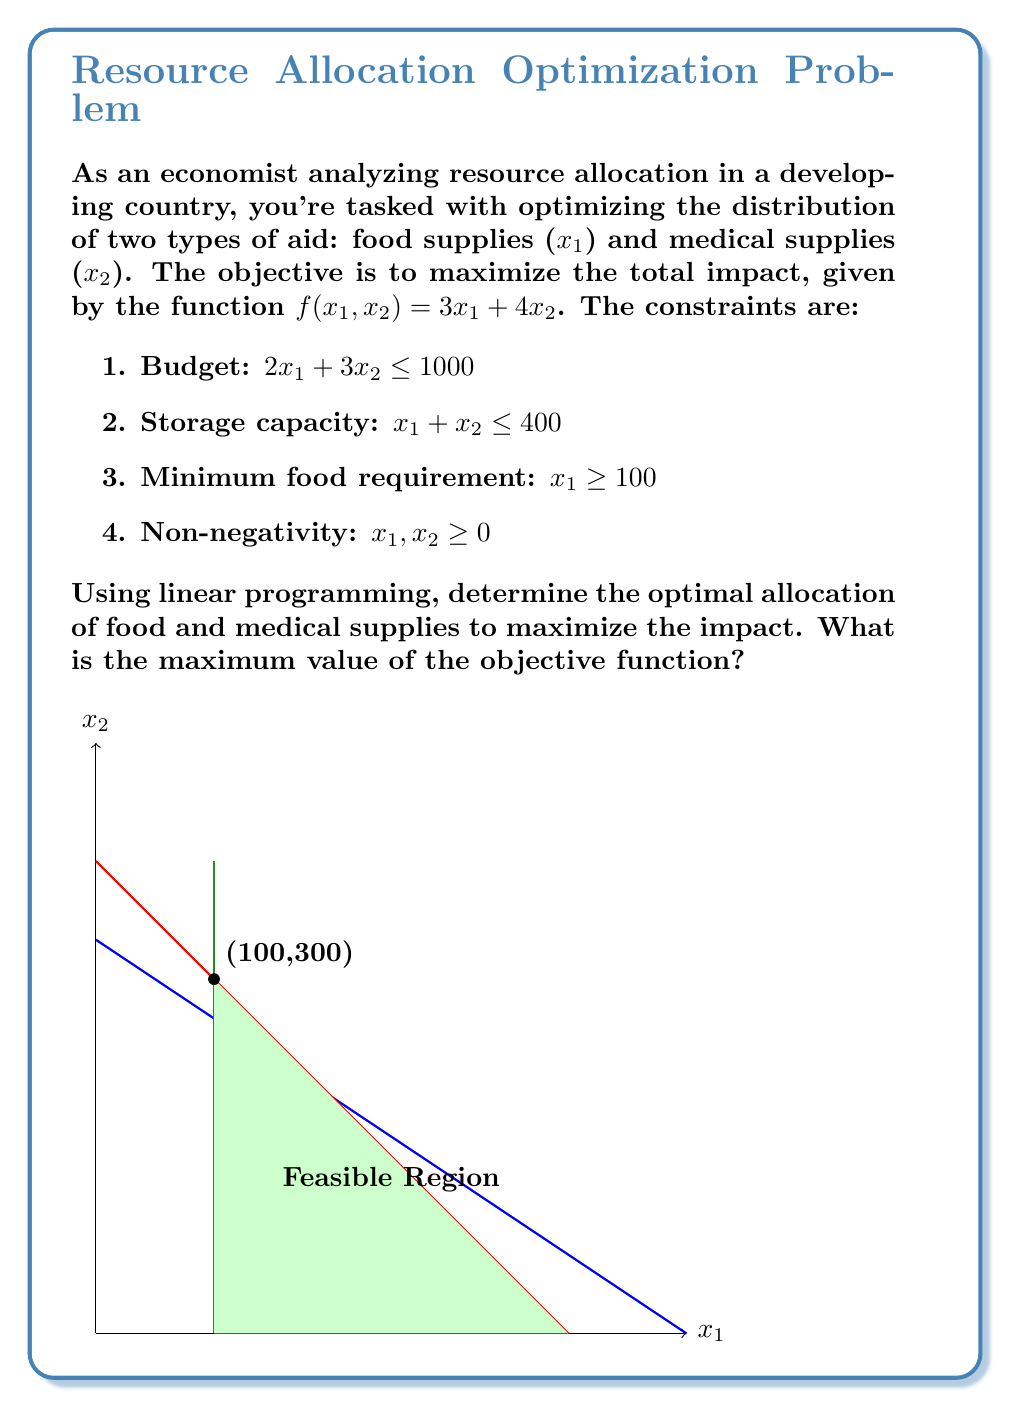Solve this math problem. Let's solve this step-by-step using the simplex method:

1) First, we identify the corners of the feasible region:
   (100,0), (400,0), (100,300), and (0,333.33)

2) We evaluate the objective function at each corner:
   f(100,0) = 300
   f(400,0) = 1200
   f(100,300) = 1500
   f(0,333.33) = 1333.33

3) The maximum value occurs at the point (100,300).

4) To verify, we can set up the standard form of the linear program:
   Maximize: $Z = 3x_1 + 4x_2$
   Subject to:
   $2x_1 + 3x_2 + s_1 = 1000$
   $x_1 + x_2 + s_2 = 400$
   $x_1 - s_3 + s_4 = 100$
   $x_1, x_2, s_1, s_2, s_3, s_4 \geq 0$

5) The initial tableau:

$$
\begin{array}{c|cccccc|c}
 & x_1 & x_2 & s_1 & s_2 & s_3 & s_4 & RHS \\
\hline
s_1 & 2 & 3 & 1 & 0 & 0 & 0 & 1000 \\
s_2 & 1 & 1 & 0 & 1 & 0 & 0 & 400 \\
s_4 & 1 & 0 & 0 & 0 & -1 & 1 & 100 \\
\hline
Z & -3 & -4 & 0 & 0 & 0 & 0 & 0
\end{array}
$$

6) After pivoting operations, we reach the optimal solution:

$$
\begin{array}{c|cccccc|c}
 & x_1 & x_2 & s_1 & s_2 & s_3 & s_4 & RHS \\
\hline
x_1 & 1 & 0 & 0 & 0 & -1 & 1 & 100 \\
x_2 & 0 & 1 & 0 & 1 & 1 & -1 & 300 \\
s_1 & 0 & 0 & 1 & -3 & -5 & 2 & 100 \\
\hline
Z & 0 & 0 & 0 & 1 & 1 & -1 & 1500
\end{array}
$$

7) This confirms our earlier conclusion: the optimal solution is $x_1 = 100$, $x_2 = 300$, with a maximum objective value of 1500.
Answer: 1500 